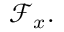Convert formula to latex. <formula><loc_0><loc_0><loc_500><loc_500>{ \mathcal { F } } _ { x } .</formula> 